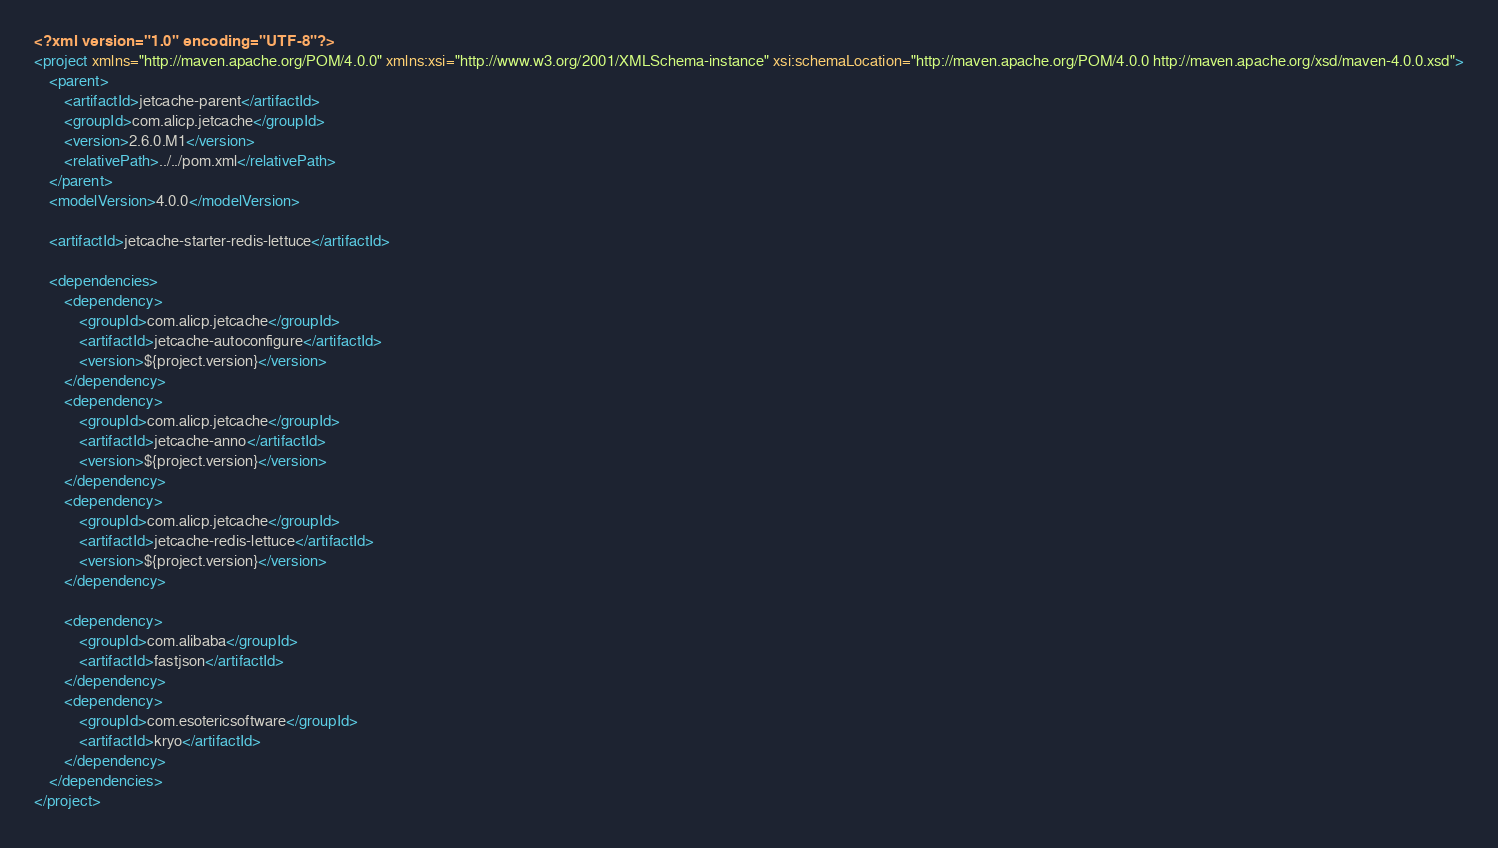Convert code to text. <code><loc_0><loc_0><loc_500><loc_500><_XML_><?xml version="1.0" encoding="UTF-8"?>
<project xmlns="http://maven.apache.org/POM/4.0.0" xmlns:xsi="http://www.w3.org/2001/XMLSchema-instance" xsi:schemaLocation="http://maven.apache.org/POM/4.0.0 http://maven.apache.org/xsd/maven-4.0.0.xsd">
    <parent>
        <artifactId>jetcache-parent</artifactId>
        <groupId>com.alicp.jetcache</groupId>
        <version>2.6.0.M1</version>
        <relativePath>../../pom.xml</relativePath>
    </parent>
    <modelVersion>4.0.0</modelVersion>

    <artifactId>jetcache-starter-redis-lettuce</artifactId>

    <dependencies>
        <dependency>
            <groupId>com.alicp.jetcache</groupId>
            <artifactId>jetcache-autoconfigure</artifactId>
            <version>${project.version}</version>
        </dependency>
        <dependency>
            <groupId>com.alicp.jetcache</groupId>
            <artifactId>jetcache-anno</artifactId>
            <version>${project.version}</version>
        </dependency>
        <dependency>
            <groupId>com.alicp.jetcache</groupId>
            <artifactId>jetcache-redis-lettuce</artifactId>
            <version>${project.version}</version>
        </dependency>

        <dependency>
            <groupId>com.alibaba</groupId>
            <artifactId>fastjson</artifactId>
        </dependency>
        <dependency>
            <groupId>com.esotericsoftware</groupId>
            <artifactId>kryo</artifactId>
        </dependency>
    </dependencies>
</project></code> 